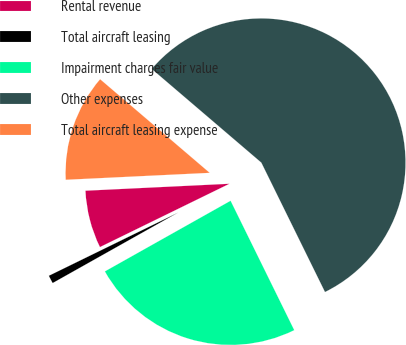<chart> <loc_0><loc_0><loc_500><loc_500><pie_chart><fcel>Rental revenue<fcel>Total aircraft leasing<fcel>Impairment charges fair value<fcel>Other expenses<fcel>Total aircraft leasing expense<nl><fcel>6.47%<fcel>0.91%<fcel>24.13%<fcel>56.47%<fcel>12.02%<nl></chart> 